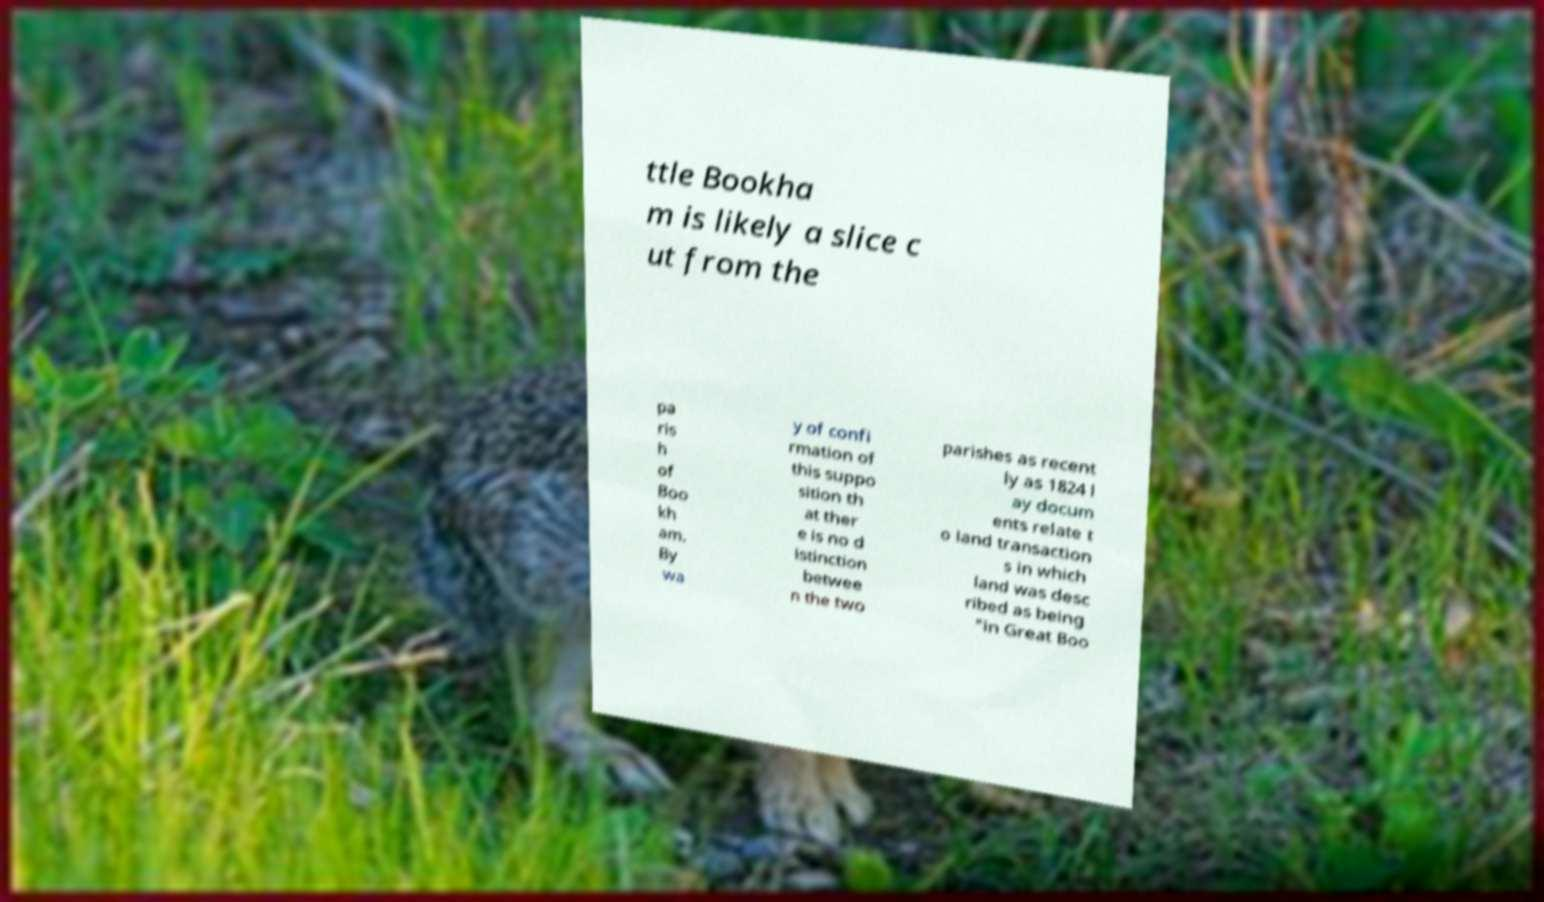For documentation purposes, I need the text within this image transcribed. Could you provide that? ttle Bookha m is likely a slice c ut from the pa ris h of Boo kh am. By wa y of confi rmation of this suppo sition th at ther e is no d istinction betwee n the two parishes as recent ly as 1824 l ay docum ents relate t o land transaction s in which land was desc ribed as being "in Great Boo 